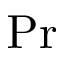Convert formula to latex. <formula><loc_0><loc_0><loc_500><loc_500>P r</formula> 